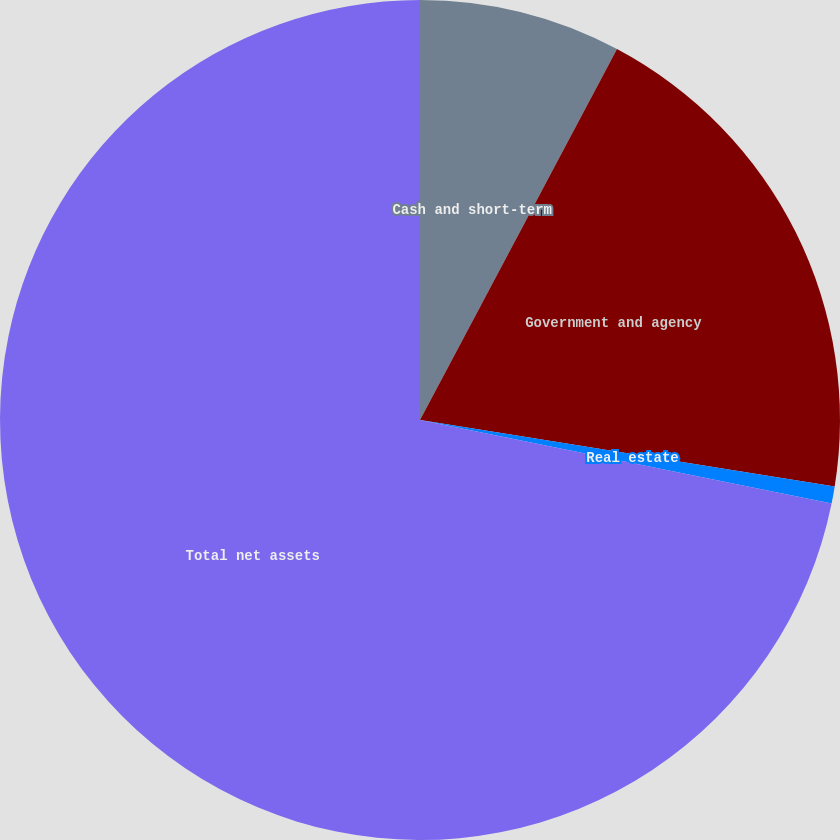<chart> <loc_0><loc_0><loc_500><loc_500><pie_chart><fcel>Cash and short-term<fcel>Government and agency<fcel>Real estate<fcel>Total net assets<nl><fcel>7.77%<fcel>19.76%<fcel>0.66%<fcel>71.81%<nl></chart> 